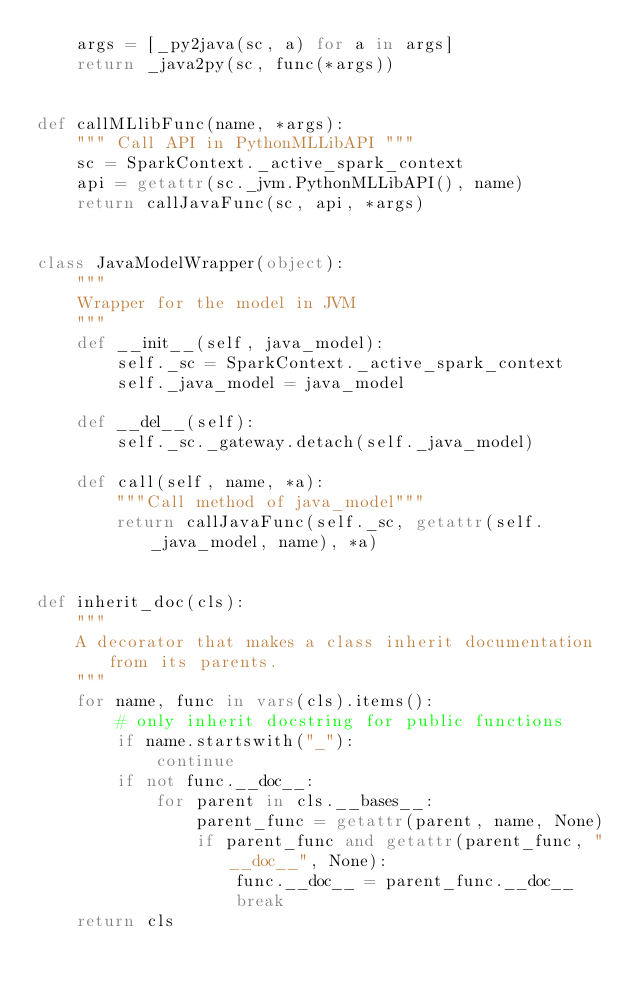<code> <loc_0><loc_0><loc_500><loc_500><_Python_>    args = [_py2java(sc, a) for a in args]
    return _java2py(sc, func(*args))


def callMLlibFunc(name, *args):
    """ Call API in PythonMLLibAPI """
    sc = SparkContext._active_spark_context
    api = getattr(sc._jvm.PythonMLLibAPI(), name)
    return callJavaFunc(sc, api, *args)


class JavaModelWrapper(object):
    """
    Wrapper for the model in JVM
    """
    def __init__(self, java_model):
        self._sc = SparkContext._active_spark_context
        self._java_model = java_model

    def __del__(self):
        self._sc._gateway.detach(self._java_model)

    def call(self, name, *a):
        """Call method of java_model"""
        return callJavaFunc(self._sc, getattr(self._java_model, name), *a)


def inherit_doc(cls):
    """
    A decorator that makes a class inherit documentation from its parents.
    """
    for name, func in vars(cls).items():
        # only inherit docstring for public functions
        if name.startswith("_"):
            continue
        if not func.__doc__:
            for parent in cls.__bases__:
                parent_func = getattr(parent, name, None)
                if parent_func and getattr(parent_func, "__doc__", None):
                    func.__doc__ = parent_func.__doc__
                    break
    return cls
</code> 